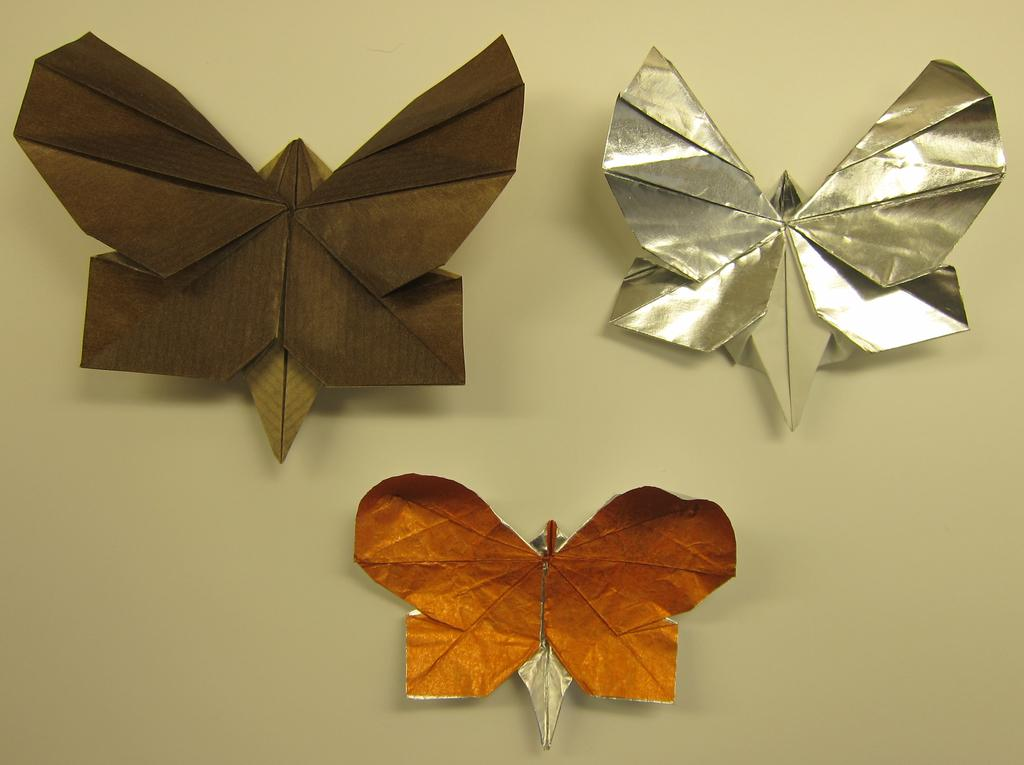What type of creatures can be seen in the image? There are butterflies in the image. What material are the butterflies made of? The butterflies are made of craft papers. Where are the butterflies located in the image? The butterflies are on the wall. What type of feast is being prepared in the image? There is no mention of a feast or any food preparation in the image; it features butterflies made of craft papers on the wall. 